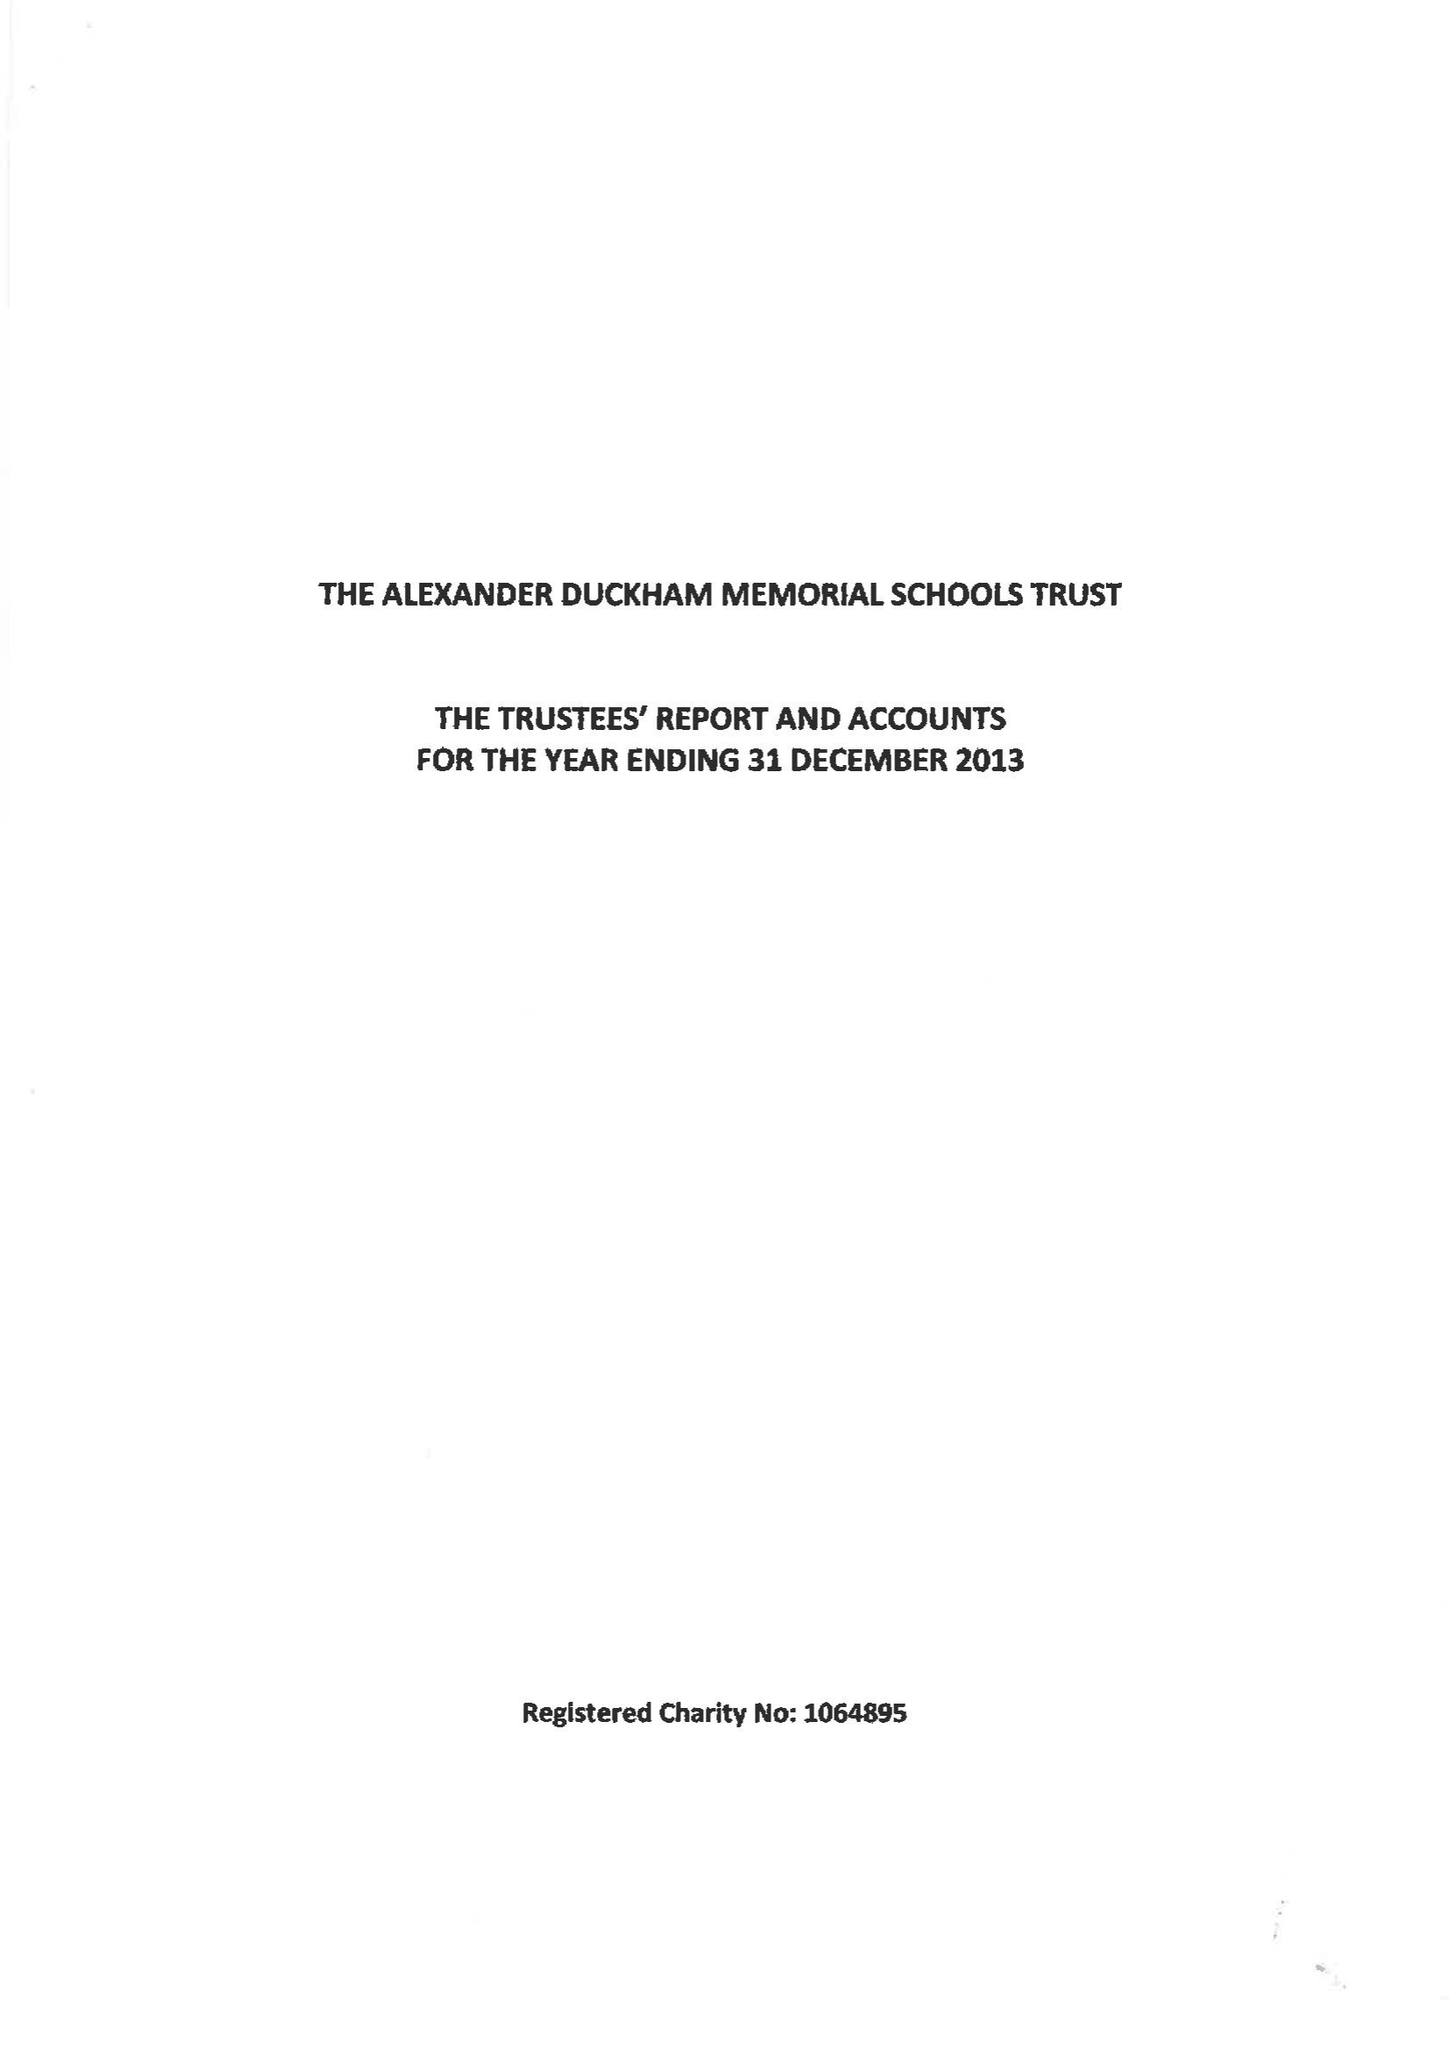What is the value for the address__post_town?
Answer the question using a single word or phrase. LONDON 